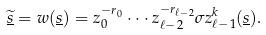Convert formula to latex. <formula><loc_0><loc_0><loc_500><loc_500>\underline { \widetilde { s } } = w ( \underline { s } ) = z _ { 0 } ^ { - r _ { 0 } } \cdot \cdot \cdot z _ { \ell - 2 } ^ { - r _ { \ell - 2 } } \sigma z _ { \ell - 1 } ^ { k } ( \underline { s } ) .</formula> 